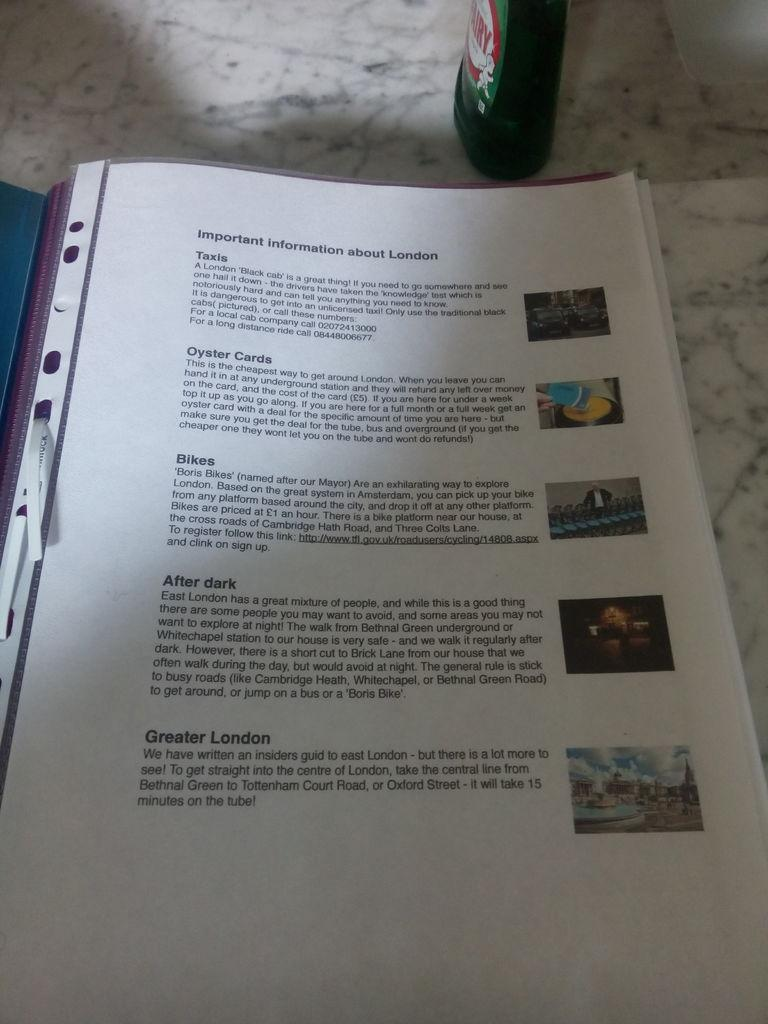<image>
Summarize the visual content of the image. An informational book on London rests on a counter top. 